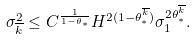Convert formula to latex. <formula><loc_0><loc_0><loc_500><loc_500>\sigma _ { \overline { k } } ^ { 2 } \leq C ^ { \frac { 1 } { 1 - \theta _ { * } } } H ^ { 2 ( 1 - \theta _ { * } ^ { \overline { k } } ) } \sigma _ { 1 } ^ { 2 \theta _ { * } ^ { \overline { k } } } .</formula> 